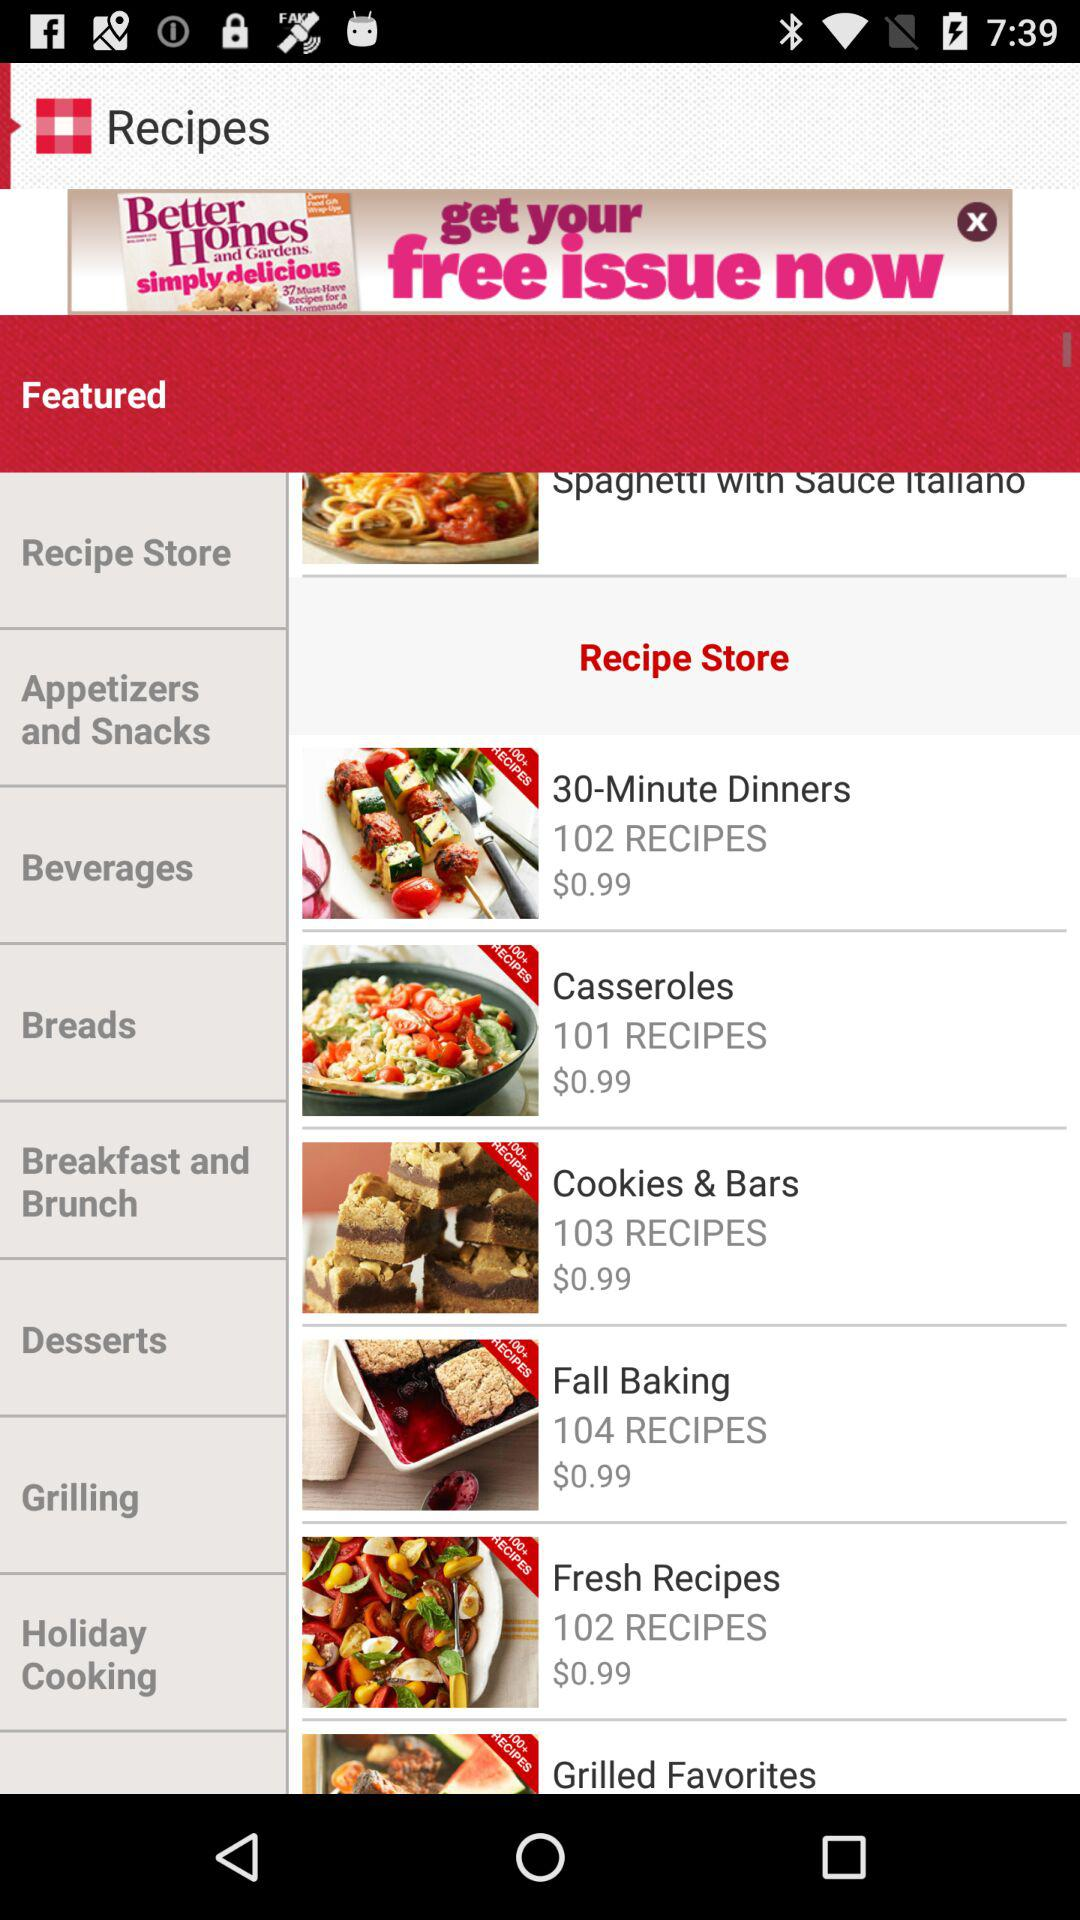What is the amount mentioned in "30-Minute Dinners"? The amount mentioned in "30-Minute Dinners" is $0.99. 